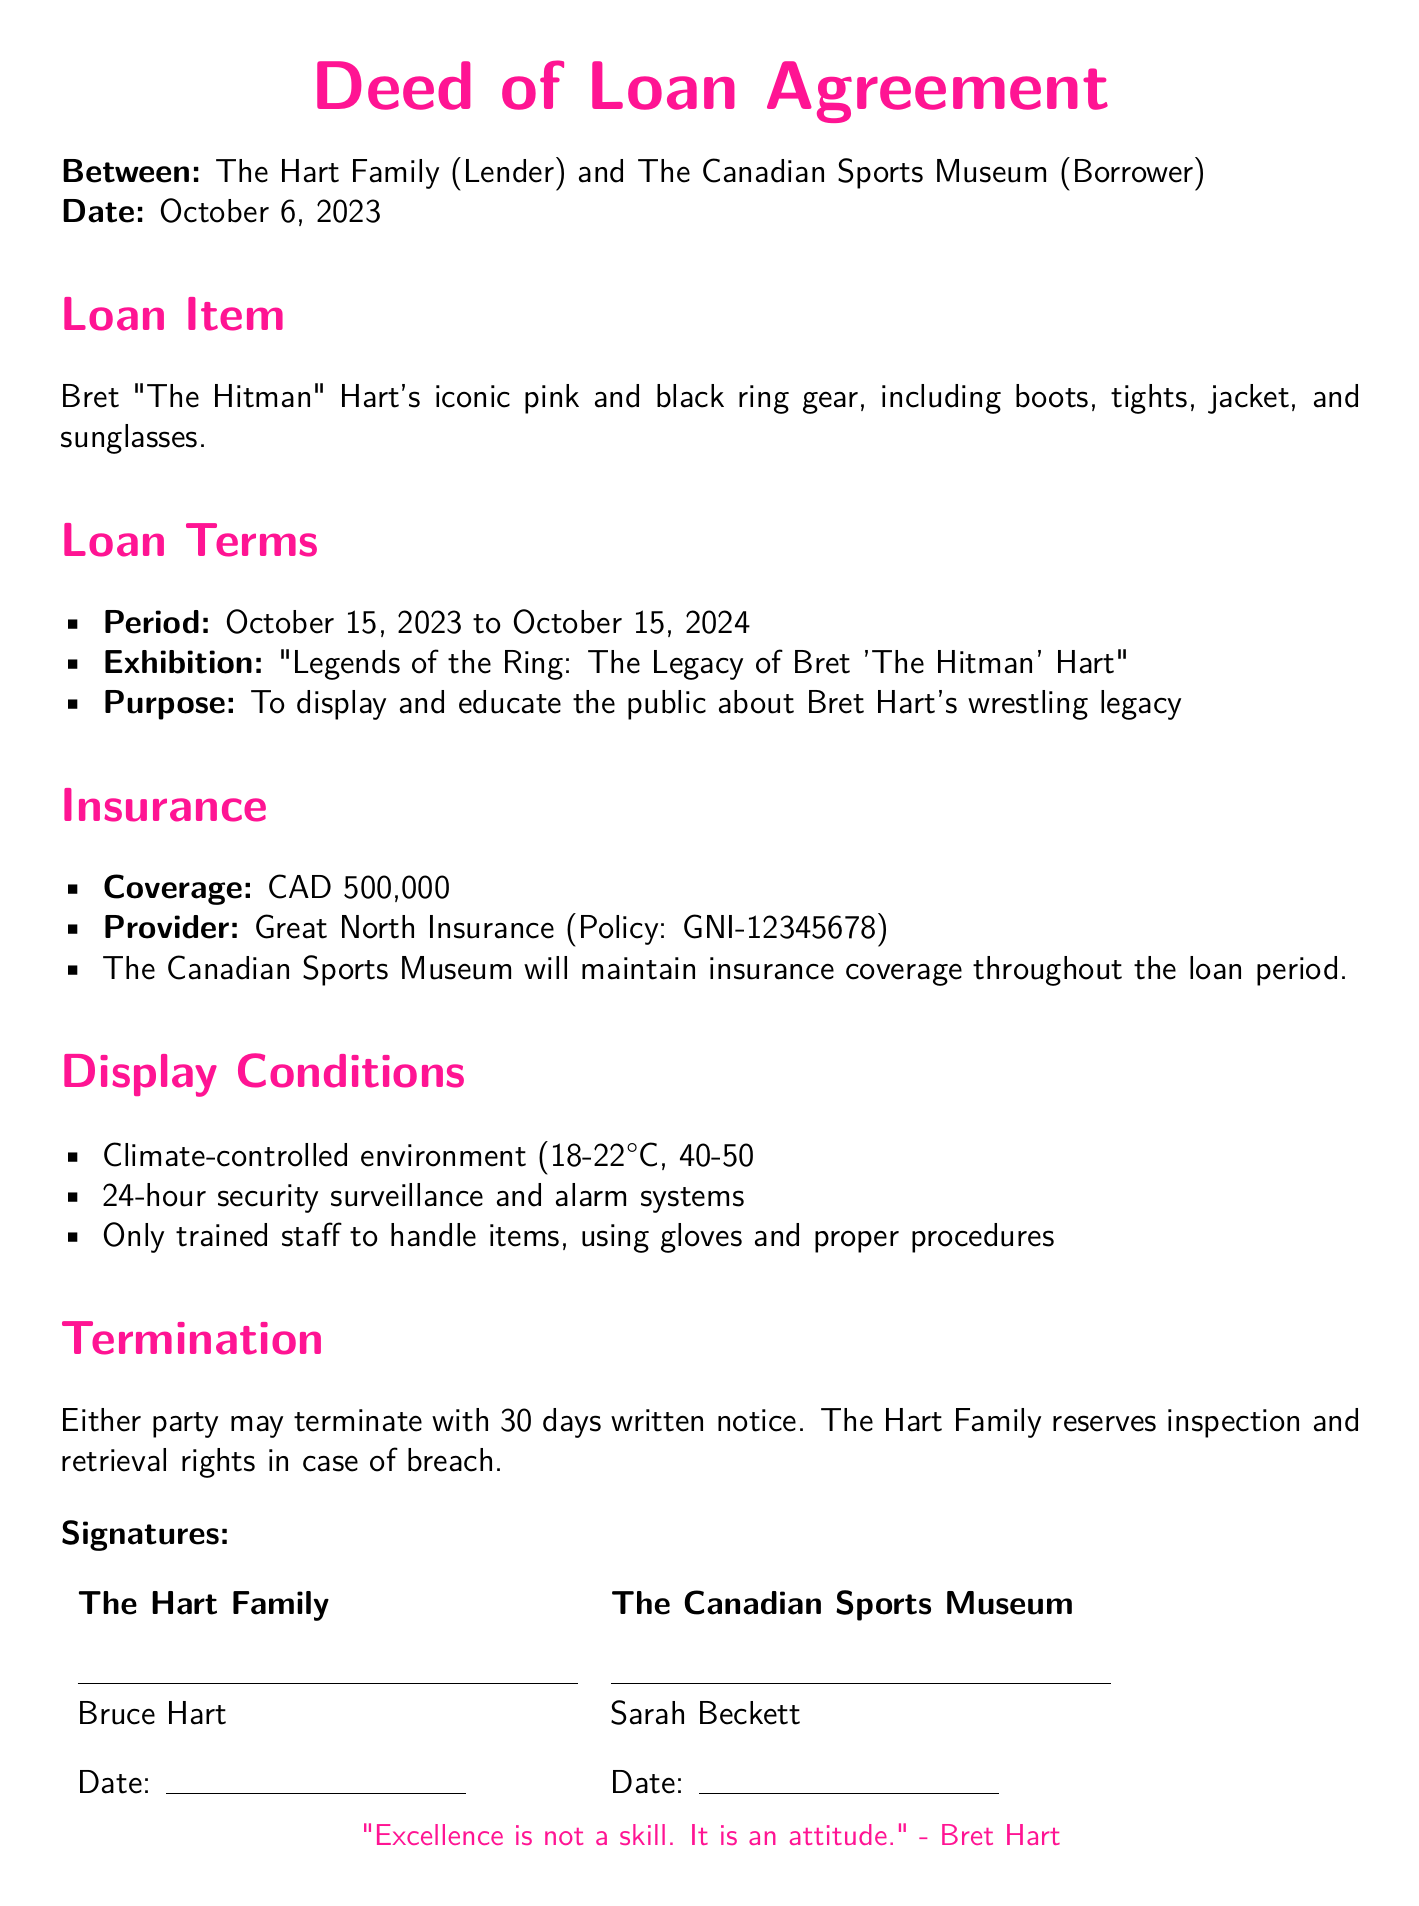What is the loan item? The document specifies that the loan item is Bret "The Hitman" Hart's iconic pink and black ring gear, including boots, tights, jacket, and sunglasses.
Answer: Bret "The Hitman" Hart's iconic pink and black ring gear What is the loan period? The loan period is explicitly mentioned in the document, starting from October 15, 2023, to October 15, 2024.
Answer: October 15, 2023 to October 15, 2024 Who is the insurance provider? The document lists the provider of the insurance coverage as Great North Insurance.
Answer: Great North Insurance What is the insurance coverage amount? The coverage amount is clearly stated as CAD 500,000 in the insurance section of the document.
Answer: CAD 500,000 What is the purpose of the exhibition? The purpose is described as displaying and educating the public about Bret Hart's wrestling legacy, as mentioned in the loan terms.
Answer: To display and educate the public about Bret Hart's wrestling legacy What are the handling conditions for the loan item? The handling conditions require only trained staff to manage items, ensuring proper handling procedures and glove use as stated in the display conditions.
Answer: Only trained staff to handle items, using gloves and proper procedures How many days' notice is needed to terminate the agreement? The document states that either party may terminate the agreement with a written notice of 30 days.
Answer: 30 days What is the name of the exhibition? The name of the exhibition is indicated in the loan terms as "Legends of the Ring: The Legacy of Bret 'The Hitman' Hart."
Answer: "Legends of the Ring: The Legacy of Bret 'The Hitman' Hart" Who is signing on behalf of The Canadian Sports Museum? The document specifically names Sarah Beckett as the person signing on behalf of The Canadian Sports Museum.
Answer: Sarah Beckett 